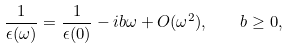Convert formula to latex. <formula><loc_0><loc_0><loc_500><loc_500>\frac { 1 } { \epsilon ( \omega ) } = \frac { 1 } { \epsilon ( 0 ) } - i b \omega + O ( \omega ^ { 2 } ) , \quad b \geq 0 ,</formula> 